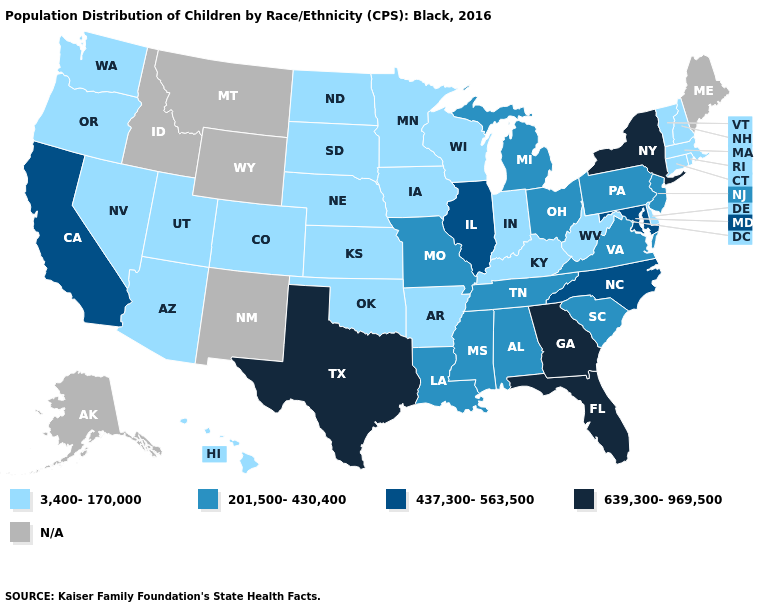What is the value of Nebraska?
Keep it brief. 3,400-170,000. What is the value of North Carolina?
Answer briefly. 437,300-563,500. Name the states that have a value in the range 639,300-969,500?
Keep it brief. Florida, Georgia, New York, Texas. Which states have the lowest value in the West?
Be succinct. Arizona, Colorado, Hawaii, Nevada, Oregon, Utah, Washington. What is the value of Maryland?
Quick response, please. 437,300-563,500. Name the states that have a value in the range 639,300-969,500?
Give a very brief answer. Florida, Georgia, New York, Texas. What is the value of Vermont?
Write a very short answer. 3,400-170,000. What is the highest value in states that border Maryland?
Give a very brief answer. 201,500-430,400. Which states have the highest value in the USA?
Write a very short answer. Florida, Georgia, New York, Texas. Name the states that have a value in the range N/A?
Concise answer only. Alaska, Idaho, Maine, Montana, New Mexico, Wyoming. Which states have the lowest value in the USA?
Short answer required. Arizona, Arkansas, Colorado, Connecticut, Delaware, Hawaii, Indiana, Iowa, Kansas, Kentucky, Massachusetts, Minnesota, Nebraska, Nevada, New Hampshire, North Dakota, Oklahoma, Oregon, Rhode Island, South Dakota, Utah, Vermont, Washington, West Virginia, Wisconsin. How many symbols are there in the legend?
Quick response, please. 5. 